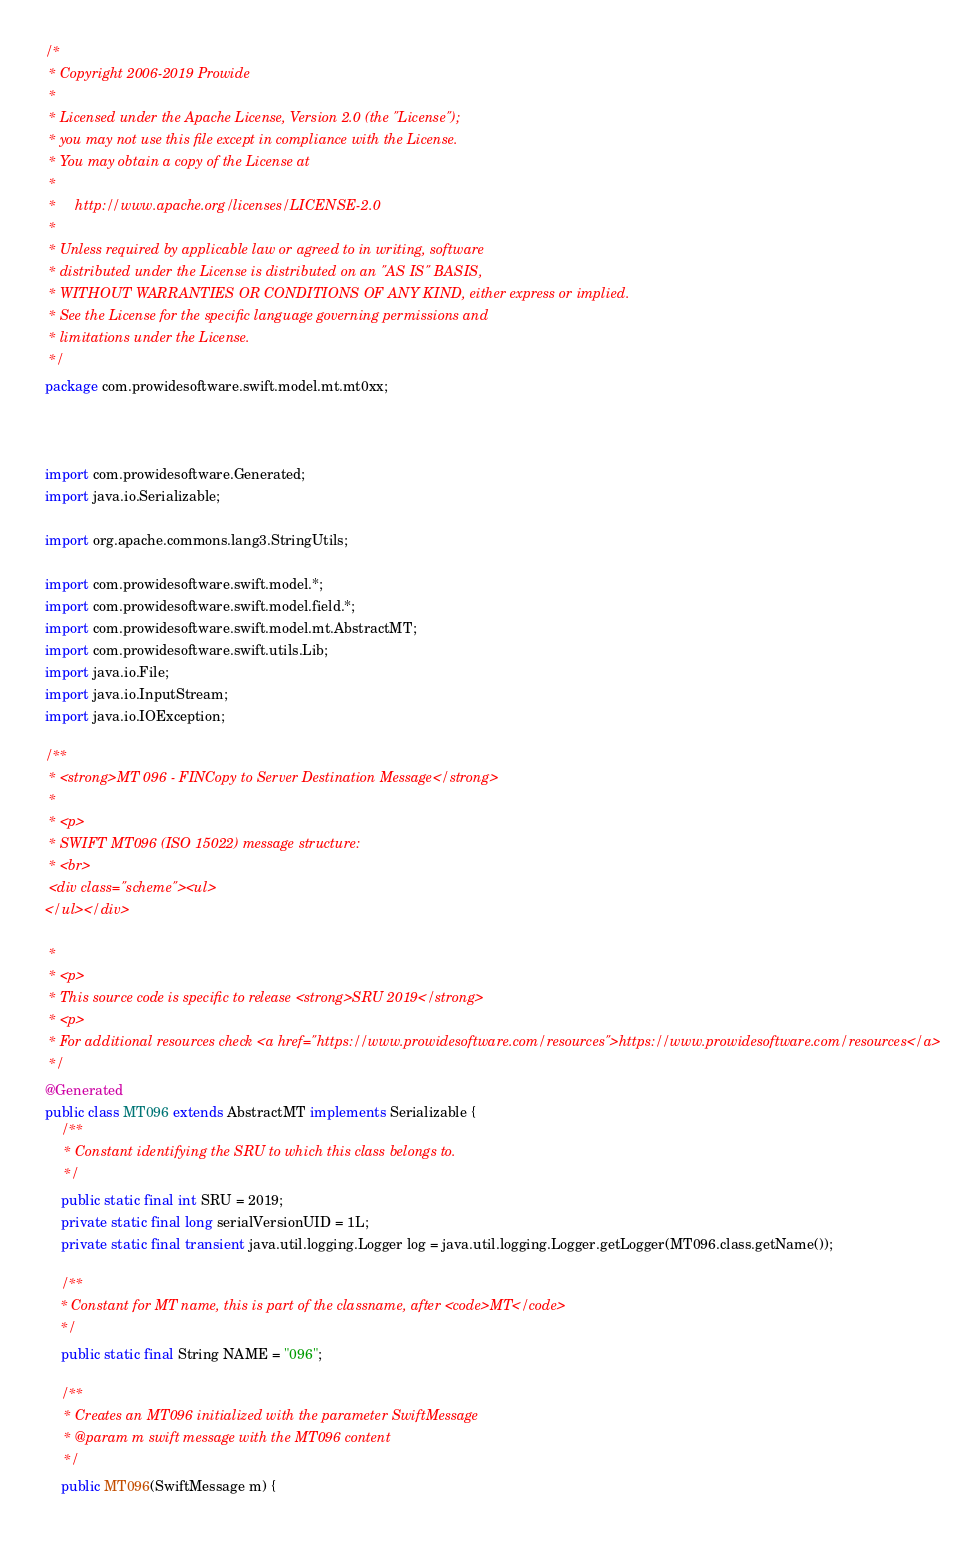<code> <loc_0><loc_0><loc_500><loc_500><_Java_>/*
 * Copyright 2006-2019 Prowide
 *
 * Licensed under the Apache License, Version 2.0 (the "License");
 * you may not use this file except in compliance with the License.
 * You may obtain a copy of the License at
 *
 *     http://www.apache.org/licenses/LICENSE-2.0
 *
 * Unless required by applicable law or agreed to in writing, software
 * distributed under the License is distributed on an "AS IS" BASIS,
 * WITHOUT WARRANTIES OR CONDITIONS OF ANY KIND, either express or implied.
 * See the License for the specific language governing permissions and
 * limitations under the License.
 */
package com.prowidesoftware.swift.model.mt.mt0xx;



import com.prowidesoftware.Generated;
import java.io.Serializable;

import org.apache.commons.lang3.StringUtils;

import com.prowidesoftware.swift.model.*;
import com.prowidesoftware.swift.model.field.*;
import com.prowidesoftware.swift.model.mt.AbstractMT;
import com.prowidesoftware.swift.utils.Lib;
import java.io.File;
import java.io.InputStream;
import java.io.IOException;

/**
 * <strong>MT 096 - FINCopy to Server Destination Message</strong>
 *
 * <p>
 * SWIFT MT096 (ISO 15022) message structure:
 * <br>
 <div class="scheme"><ul>
</ul></div>

 *
 * <p>
 * This source code is specific to release <strong>SRU 2019</strong>
 * <p>
 * For additional resources check <a href="https://www.prowidesoftware.com/resources">https://www.prowidesoftware.com/resources</a>
 */
@Generated
public class MT096 extends AbstractMT implements Serializable {
	/**
	 * Constant identifying the SRU to which this class belongs to.
	 */
	public static final int SRU = 2019;
	private static final long serialVersionUID = 1L;
	private static final transient java.util.logging.Logger log = java.util.logging.Logger.getLogger(MT096.class.getName());
	
	/**
	* Constant for MT name, this is part of the classname, after <code>MT</code>
	*/
	public static final String NAME = "096";

	/**
	 * Creates an MT096 initialized with the parameter SwiftMessage
	 * @param m swift message with the MT096 content
	 */
	public MT096(SwiftMessage m) {</code> 